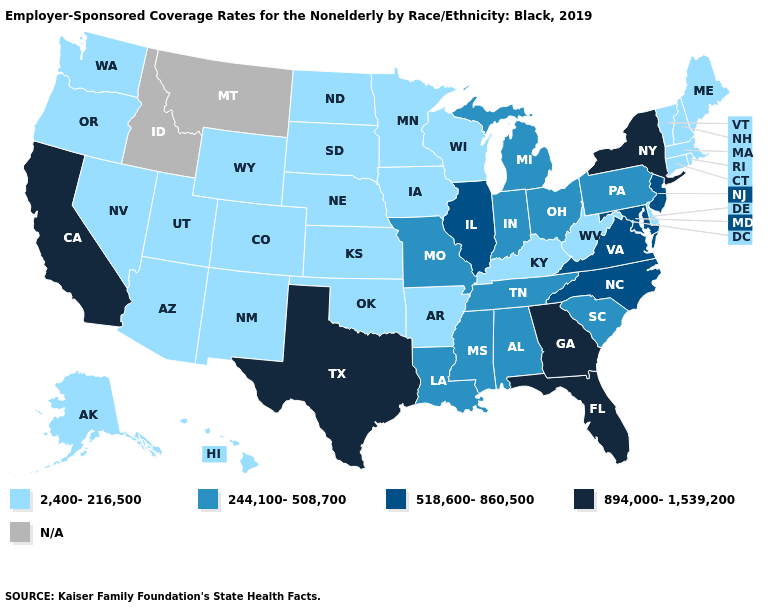Does the map have missing data?
Give a very brief answer. Yes. Does the first symbol in the legend represent the smallest category?
Keep it brief. Yes. What is the lowest value in the Northeast?
Quick response, please. 2,400-216,500. Does the first symbol in the legend represent the smallest category?
Give a very brief answer. Yes. What is the value of North Dakota?
Quick response, please. 2,400-216,500. Is the legend a continuous bar?
Write a very short answer. No. What is the value of New York?
Quick response, please. 894,000-1,539,200. Name the states that have a value in the range N/A?
Give a very brief answer. Idaho, Montana. What is the lowest value in the MidWest?
Keep it brief. 2,400-216,500. Name the states that have a value in the range 244,100-508,700?
Keep it brief. Alabama, Indiana, Louisiana, Michigan, Mississippi, Missouri, Ohio, Pennsylvania, South Carolina, Tennessee. What is the lowest value in the South?
Be succinct. 2,400-216,500. What is the value of Nebraska?
Quick response, please. 2,400-216,500. Name the states that have a value in the range 2,400-216,500?
Keep it brief. Alaska, Arizona, Arkansas, Colorado, Connecticut, Delaware, Hawaii, Iowa, Kansas, Kentucky, Maine, Massachusetts, Minnesota, Nebraska, Nevada, New Hampshire, New Mexico, North Dakota, Oklahoma, Oregon, Rhode Island, South Dakota, Utah, Vermont, Washington, West Virginia, Wisconsin, Wyoming. 